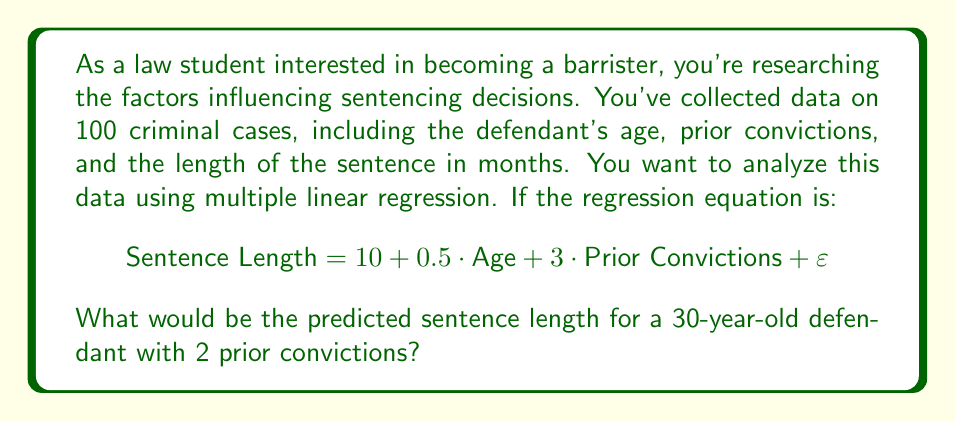Solve this math problem. To solve this problem, we'll follow these steps:

1. Identify the regression equation:
   $$\text{Sentence Length} = 10 + 0.5 \cdot \text{Age} + 3 \cdot \text{Prior Convictions} + \varepsilon$$

2. Identify the given values:
   - Age = 30
   - Prior Convictions = 2

3. Substitute these values into the equation:
   $$\text{Sentence Length} = 10 + 0.5 \cdot 30 + 3 \cdot 2 + \varepsilon$$

4. Calculate each term:
   - Constant term: 10
   - Age term: $0.5 \cdot 30 = 15$
   - Prior Convictions term: $3 \cdot 2 = 6$

5. Sum up the terms:
   $$\text{Sentence Length} = 10 + 15 + 6 + \varepsilon = 31 + \varepsilon$$

6. Since $\varepsilon$ represents the error term (which we assume to be zero for prediction purposes), our final predicted sentence length is 31 months.
Answer: 31 months 